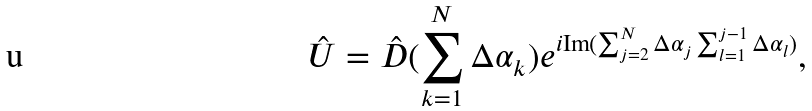Convert formula to latex. <formula><loc_0><loc_0><loc_500><loc_500>\hat { U } = \hat { D } ( \sum _ { k = 1 } ^ { N } \Delta \alpha _ { k } ) e ^ { i \text {Im} ( \sum _ { j = 2 } ^ { N } \Delta \alpha _ { j } \sum _ { l = 1 } ^ { j - 1 } \Delta \alpha _ { l } ) } ,</formula> 